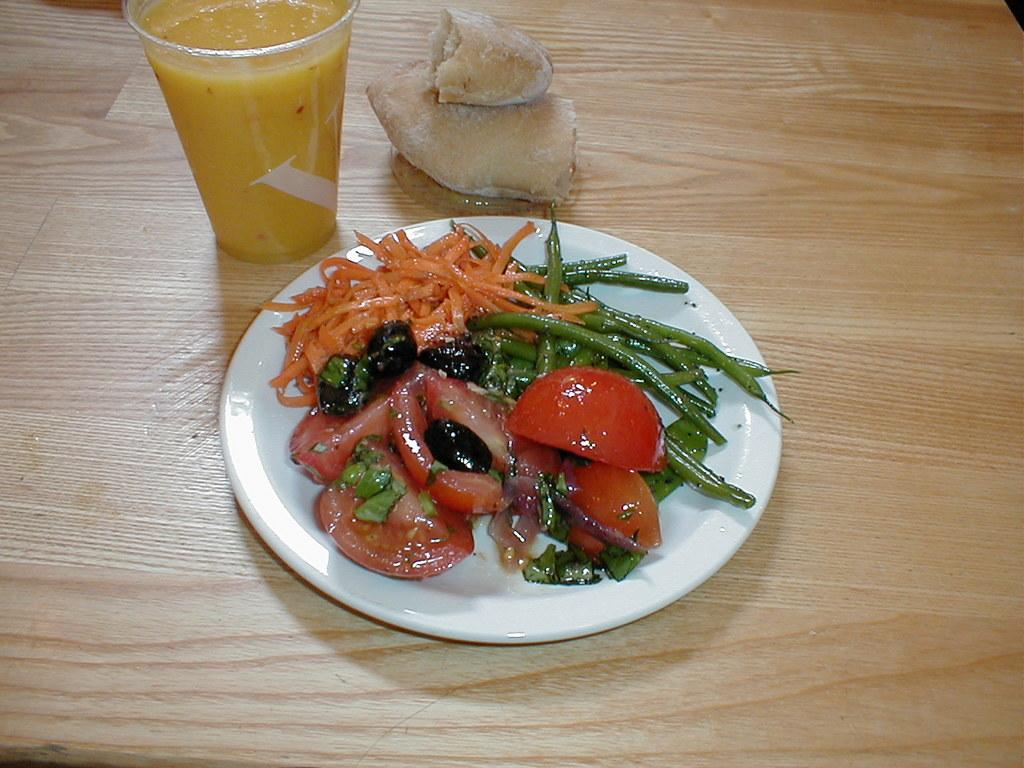What type of surface can be seen in the image? There is a wooden surface in the image. What is placed on the wooden surface? There are items placed on the wooden surface in the image. What can be found on the plate in the image? There is a plate with a food item on it. What is contained in the glass in the image? There is a glass with juice in the image. What type of laborer is depicted in the image? There is no laborer present in the image. Can you tell me the name of the judge in the image? There is no judge present in the image. 